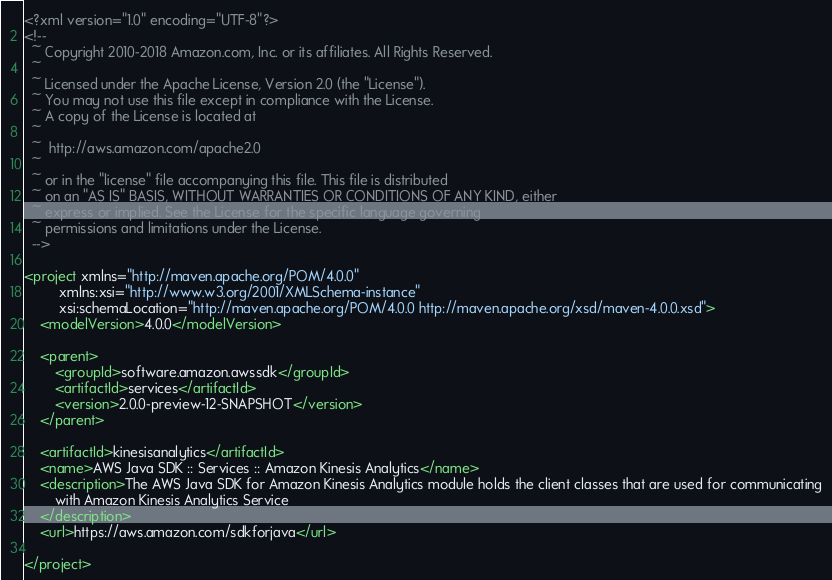<code> <loc_0><loc_0><loc_500><loc_500><_XML_><?xml version="1.0" encoding="UTF-8"?>
<!--
  ~ Copyright 2010-2018 Amazon.com, Inc. or its affiliates. All Rights Reserved.
  ~  
  ~ Licensed under the Apache License, Version 2.0 (the "License").
  ~ You may not use this file except in compliance with the License.
  ~ A copy of the License is located at
  ~  
  ~  http://aws.amazon.com/apache2.0
  ~  
  ~ or in the "license" file accompanying this file. This file is distributed
  ~ on an "AS IS" BASIS, WITHOUT WARRANTIES OR CONDITIONS OF ANY KIND, either
  ~ express or implied. See the License for the specific language governing
  ~ permissions and limitations under the License.
  -->

<project xmlns="http://maven.apache.org/POM/4.0.0"
         xmlns:xsi="http://www.w3.org/2001/XMLSchema-instance"
         xsi:schemaLocation="http://maven.apache.org/POM/4.0.0 http://maven.apache.org/xsd/maven-4.0.0.xsd">
    <modelVersion>4.0.0</modelVersion>

    <parent>
        <groupId>software.amazon.awssdk</groupId>
        <artifactId>services</artifactId>
        <version>2.0.0-preview-12-SNAPSHOT</version>
    </parent>

    <artifactId>kinesisanalytics</artifactId>
    <name>AWS Java SDK :: Services :: Amazon Kinesis Analytics</name>
    <description>The AWS Java SDK for Amazon Kinesis Analytics module holds the client classes that are used for communicating
        with Amazon Kinesis Analytics Service
    </description>
    <url>https://aws.amazon.com/sdkforjava</url>

</project></code> 